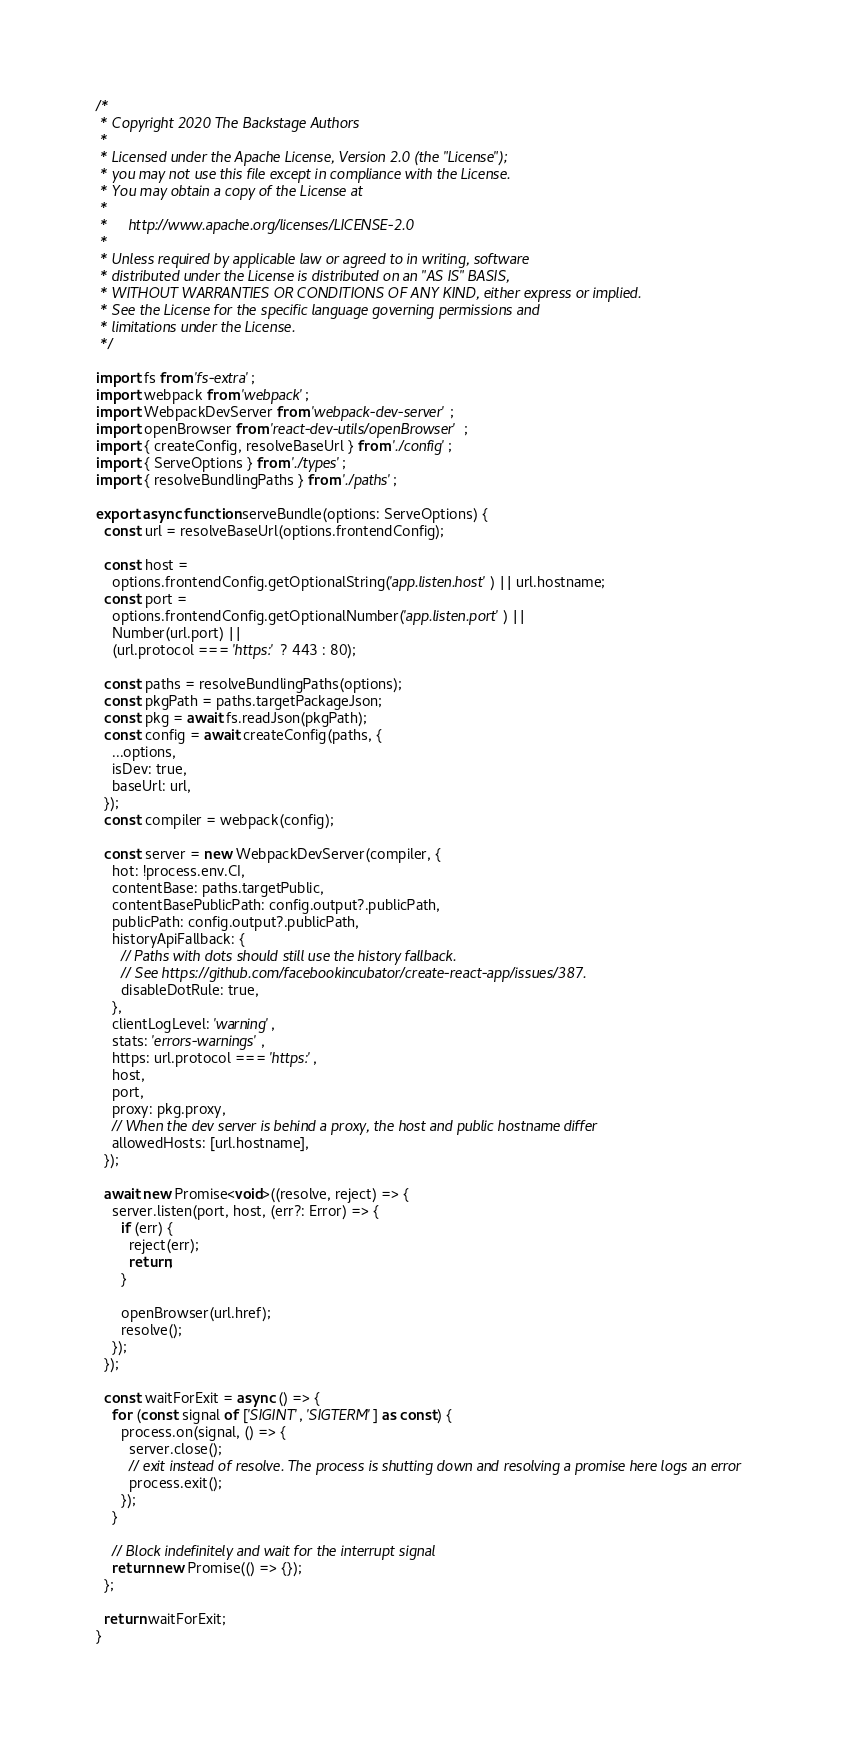<code> <loc_0><loc_0><loc_500><loc_500><_TypeScript_>/*
 * Copyright 2020 The Backstage Authors
 *
 * Licensed under the Apache License, Version 2.0 (the "License");
 * you may not use this file except in compliance with the License.
 * You may obtain a copy of the License at
 *
 *     http://www.apache.org/licenses/LICENSE-2.0
 *
 * Unless required by applicable law or agreed to in writing, software
 * distributed under the License is distributed on an "AS IS" BASIS,
 * WITHOUT WARRANTIES OR CONDITIONS OF ANY KIND, either express or implied.
 * See the License for the specific language governing permissions and
 * limitations under the License.
 */

import fs from 'fs-extra';
import webpack from 'webpack';
import WebpackDevServer from 'webpack-dev-server';
import openBrowser from 'react-dev-utils/openBrowser';
import { createConfig, resolveBaseUrl } from './config';
import { ServeOptions } from './types';
import { resolveBundlingPaths } from './paths';

export async function serveBundle(options: ServeOptions) {
  const url = resolveBaseUrl(options.frontendConfig);

  const host =
    options.frontendConfig.getOptionalString('app.listen.host') || url.hostname;
  const port =
    options.frontendConfig.getOptionalNumber('app.listen.port') ||
    Number(url.port) ||
    (url.protocol === 'https:' ? 443 : 80);

  const paths = resolveBundlingPaths(options);
  const pkgPath = paths.targetPackageJson;
  const pkg = await fs.readJson(pkgPath);
  const config = await createConfig(paths, {
    ...options,
    isDev: true,
    baseUrl: url,
  });
  const compiler = webpack(config);

  const server = new WebpackDevServer(compiler, {
    hot: !process.env.CI,
    contentBase: paths.targetPublic,
    contentBasePublicPath: config.output?.publicPath,
    publicPath: config.output?.publicPath,
    historyApiFallback: {
      // Paths with dots should still use the history fallback.
      // See https://github.com/facebookincubator/create-react-app/issues/387.
      disableDotRule: true,
    },
    clientLogLevel: 'warning',
    stats: 'errors-warnings',
    https: url.protocol === 'https:',
    host,
    port,
    proxy: pkg.proxy,
    // When the dev server is behind a proxy, the host and public hostname differ
    allowedHosts: [url.hostname],
  });

  await new Promise<void>((resolve, reject) => {
    server.listen(port, host, (err?: Error) => {
      if (err) {
        reject(err);
        return;
      }

      openBrowser(url.href);
      resolve();
    });
  });

  const waitForExit = async () => {
    for (const signal of ['SIGINT', 'SIGTERM'] as const) {
      process.on(signal, () => {
        server.close();
        // exit instead of resolve. The process is shutting down and resolving a promise here logs an error
        process.exit();
      });
    }

    // Block indefinitely and wait for the interrupt signal
    return new Promise(() => {});
  };

  return waitForExit;
}
</code> 